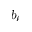Convert formula to latex. <formula><loc_0><loc_0><loc_500><loc_500>b _ { \ell }</formula> 